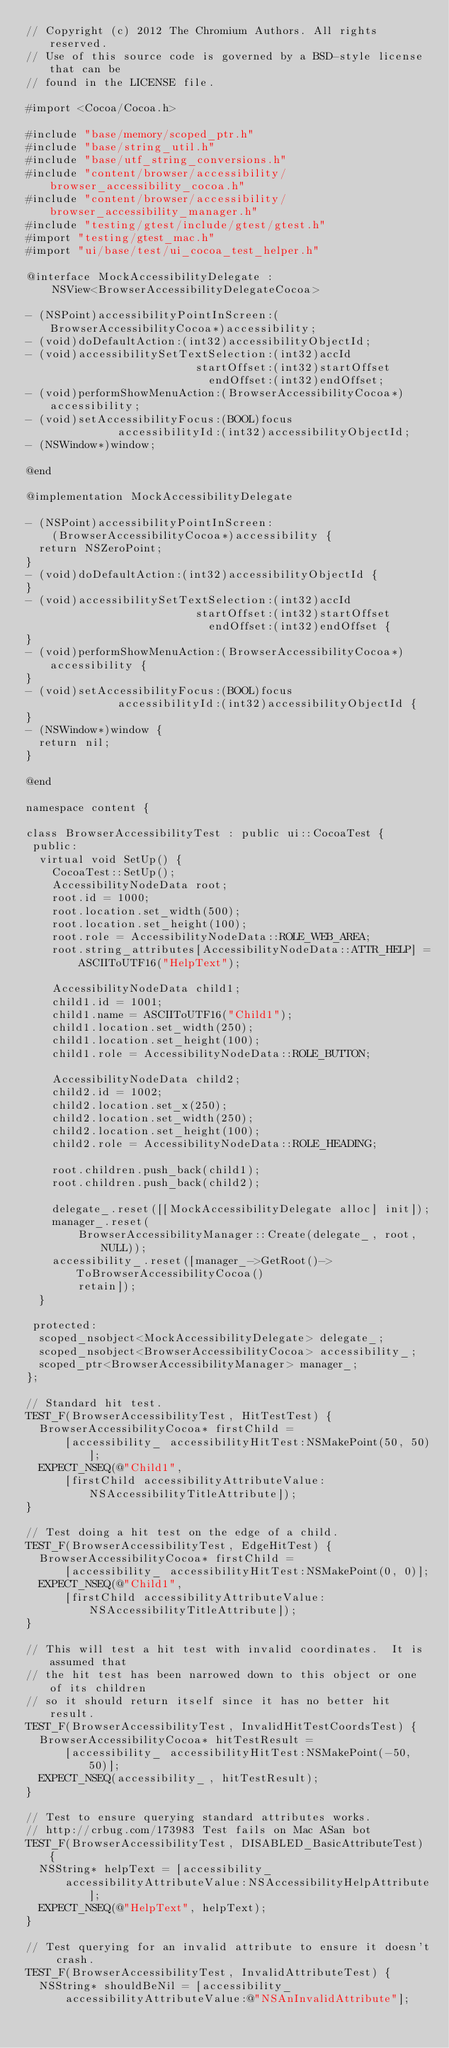<code> <loc_0><loc_0><loc_500><loc_500><_ObjectiveC_>// Copyright (c) 2012 The Chromium Authors. All rights reserved.
// Use of this source code is governed by a BSD-style license that can be
// found in the LICENSE file.

#import <Cocoa/Cocoa.h>

#include "base/memory/scoped_ptr.h"
#include "base/string_util.h"
#include "base/utf_string_conversions.h"
#include "content/browser/accessibility/browser_accessibility_cocoa.h"
#include "content/browser/accessibility/browser_accessibility_manager.h"
#include "testing/gtest/include/gtest/gtest.h"
#import "testing/gtest_mac.h"
#import "ui/base/test/ui_cocoa_test_helper.h"

@interface MockAccessibilityDelegate :
    NSView<BrowserAccessibilityDelegateCocoa>

- (NSPoint)accessibilityPointInScreen:(BrowserAccessibilityCocoa*)accessibility;
- (void)doDefaultAction:(int32)accessibilityObjectId;
- (void)accessibilitySetTextSelection:(int32)accId
                          startOffset:(int32)startOffset
                            endOffset:(int32)endOffset;
- (void)performShowMenuAction:(BrowserAccessibilityCocoa*)accessibility;
- (void)setAccessibilityFocus:(BOOL)focus
              accessibilityId:(int32)accessibilityObjectId;
- (NSWindow*)window;

@end

@implementation MockAccessibilityDelegate

- (NSPoint)accessibilityPointInScreen:
    (BrowserAccessibilityCocoa*)accessibility {
  return NSZeroPoint;
}
- (void)doDefaultAction:(int32)accessibilityObjectId {
}
- (void)accessibilitySetTextSelection:(int32)accId
                          startOffset:(int32)startOffset
                            endOffset:(int32)endOffset {
}
- (void)performShowMenuAction:(BrowserAccessibilityCocoa*)accessibility {
}
- (void)setAccessibilityFocus:(BOOL)focus
              accessibilityId:(int32)accessibilityObjectId {
}
- (NSWindow*)window {
  return nil;
}

@end

namespace content {

class BrowserAccessibilityTest : public ui::CocoaTest {
 public:
  virtual void SetUp() {
    CocoaTest::SetUp();
    AccessibilityNodeData root;
    root.id = 1000;
    root.location.set_width(500);
    root.location.set_height(100);
    root.role = AccessibilityNodeData::ROLE_WEB_AREA;
    root.string_attributes[AccessibilityNodeData::ATTR_HELP] =
        ASCIIToUTF16("HelpText");

    AccessibilityNodeData child1;
    child1.id = 1001;
    child1.name = ASCIIToUTF16("Child1");
    child1.location.set_width(250);
    child1.location.set_height(100);
    child1.role = AccessibilityNodeData::ROLE_BUTTON;

    AccessibilityNodeData child2;
    child2.id = 1002;
    child2.location.set_x(250);
    child2.location.set_width(250);
    child2.location.set_height(100);
    child2.role = AccessibilityNodeData::ROLE_HEADING;

    root.children.push_back(child1);
    root.children.push_back(child2);

    delegate_.reset([[MockAccessibilityDelegate alloc] init]);
    manager_.reset(
        BrowserAccessibilityManager::Create(delegate_, root, NULL));
    accessibility_.reset([manager_->GetRoot()->ToBrowserAccessibilityCocoa()
        retain]);
  }

 protected:
  scoped_nsobject<MockAccessibilityDelegate> delegate_;
  scoped_nsobject<BrowserAccessibilityCocoa> accessibility_;
  scoped_ptr<BrowserAccessibilityManager> manager_;
};

// Standard hit test.
TEST_F(BrowserAccessibilityTest, HitTestTest) {
  BrowserAccessibilityCocoa* firstChild =
      [accessibility_ accessibilityHitTest:NSMakePoint(50, 50)];
  EXPECT_NSEQ(@"Child1",
      [firstChild accessibilityAttributeValue:NSAccessibilityTitleAttribute]);
}

// Test doing a hit test on the edge of a child.
TEST_F(BrowserAccessibilityTest, EdgeHitTest) {
  BrowserAccessibilityCocoa* firstChild =
      [accessibility_ accessibilityHitTest:NSMakePoint(0, 0)];
  EXPECT_NSEQ(@"Child1",
      [firstChild accessibilityAttributeValue:NSAccessibilityTitleAttribute]);
}

// This will test a hit test with invalid coordinates.  It is assumed that
// the hit test has been narrowed down to this object or one of its children
// so it should return itself since it has no better hit result.
TEST_F(BrowserAccessibilityTest, InvalidHitTestCoordsTest) {
  BrowserAccessibilityCocoa* hitTestResult =
      [accessibility_ accessibilityHitTest:NSMakePoint(-50, 50)];
  EXPECT_NSEQ(accessibility_, hitTestResult);
}

// Test to ensure querying standard attributes works.
// http://crbug.com/173983 Test fails on Mac ASan bot
TEST_F(BrowserAccessibilityTest, DISABLED_BasicAttributeTest) {
  NSString* helpText = [accessibility_
      accessibilityAttributeValue:NSAccessibilityHelpAttribute];
  EXPECT_NSEQ(@"HelpText", helpText);
}

// Test querying for an invalid attribute to ensure it doesn't crash.
TEST_F(BrowserAccessibilityTest, InvalidAttributeTest) {
  NSString* shouldBeNil = [accessibility_
      accessibilityAttributeValue:@"NSAnInvalidAttribute"];</code> 